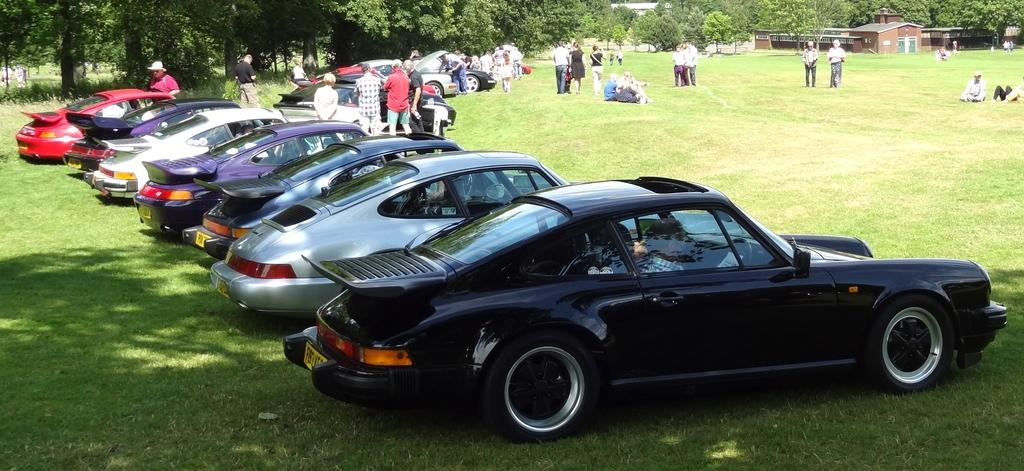What type of vehicles can be seen in the image? There are cars in the image. What are the people in the image doing? Some people are sitting on the grass, while others are standing on the grass. Can you describe the location of the house in the image? There is a house in the image. What can be seen in the background of the image? There are trees in the background of the image. What type of organization is responsible for the motion of the zinc in the image? There is no zinc present in the image, and therefore no motion or organization related to it. 